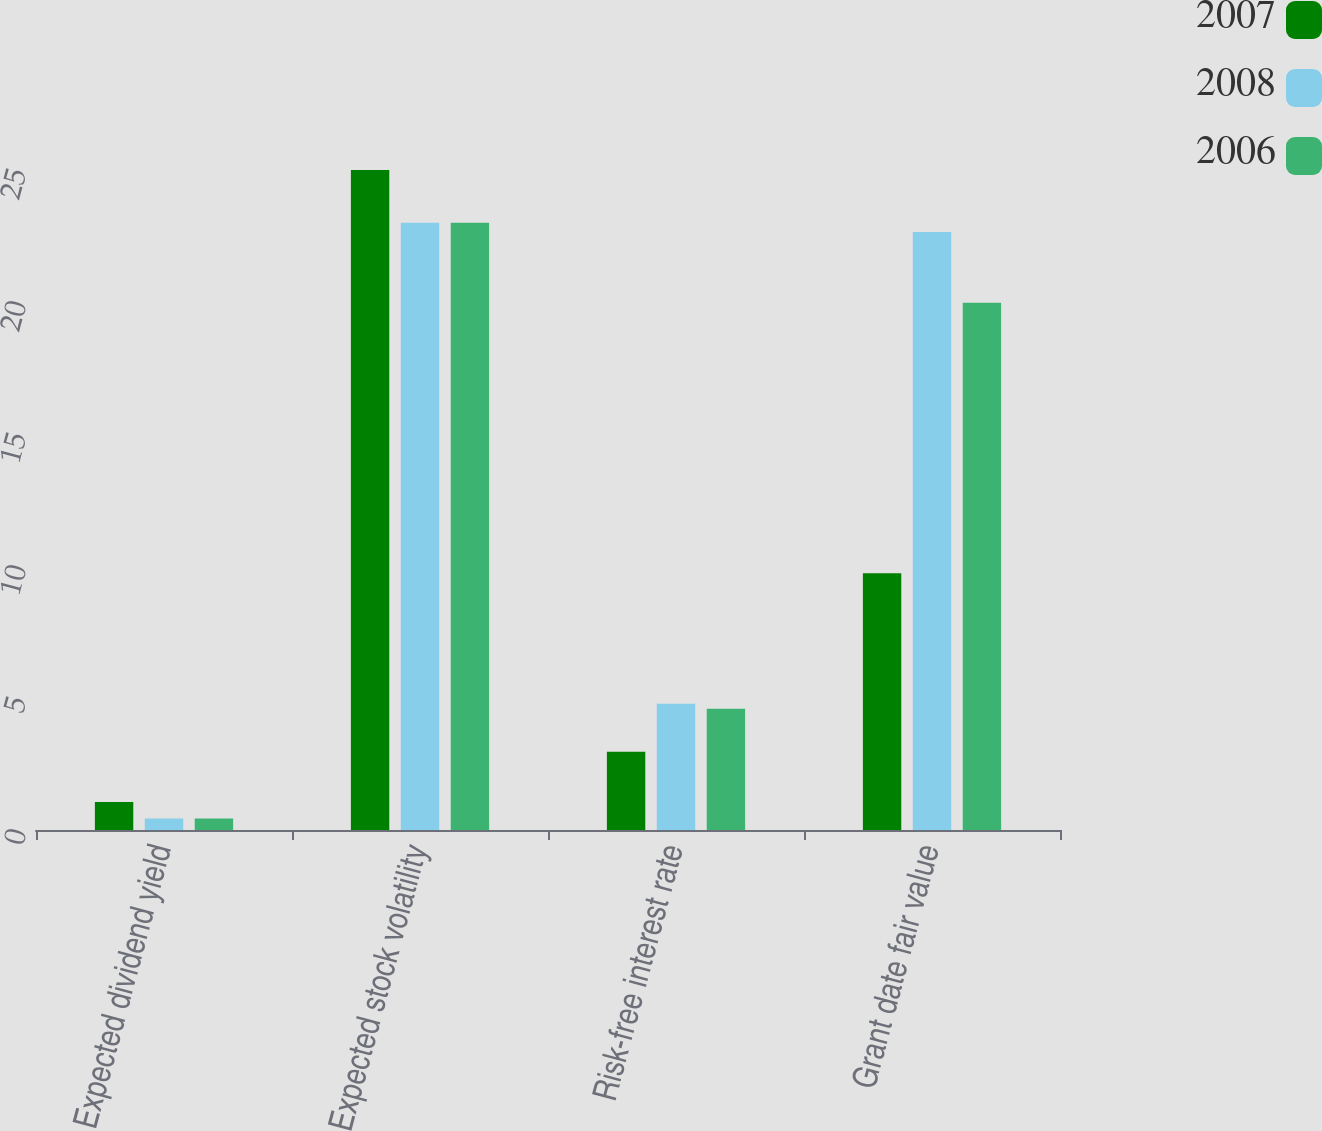<chart> <loc_0><loc_0><loc_500><loc_500><stacked_bar_chart><ecel><fcel>Expected dividend yield<fcel>Expected stock volatility<fcel>Risk-free interest rate<fcel>Grant date fair value<nl><fcel>2007<fcel>1.06<fcel>25<fcel>2.96<fcel>9.73<nl><fcel>2008<fcel>0.44<fcel>23<fcel>4.78<fcel>22.65<nl><fcel>2006<fcel>0.44<fcel>23<fcel>4.59<fcel>19.97<nl></chart> 